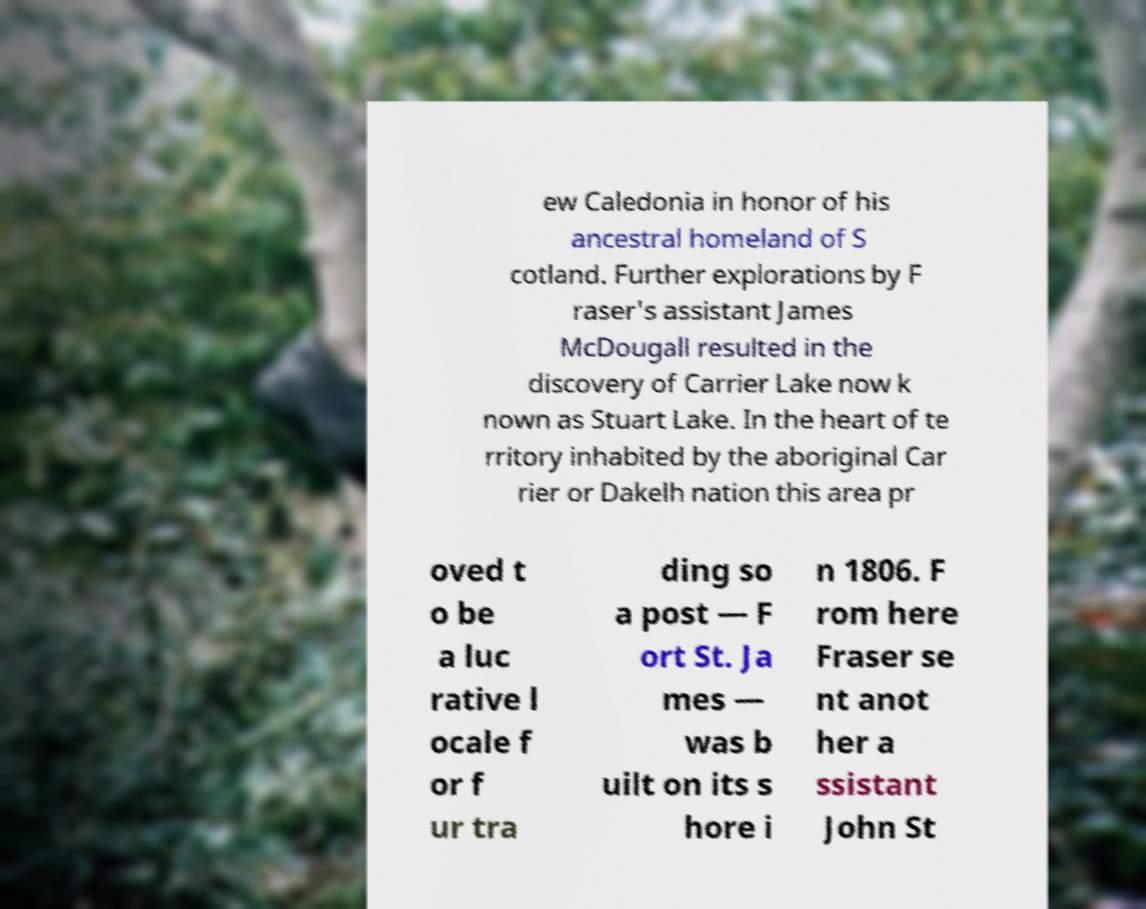Could you extract and type out the text from this image? ew Caledonia in honor of his ancestral homeland of S cotland. Further explorations by F raser's assistant James McDougall resulted in the discovery of Carrier Lake now k nown as Stuart Lake. In the heart of te rritory inhabited by the aboriginal Car rier or Dakelh nation this area pr oved t o be a luc rative l ocale f or f ur tra ding so a post — F ort St. Ja mes — was b uilt on its s hore i n 1806. F rom here Fraser se nt anot her a ssistant John St 